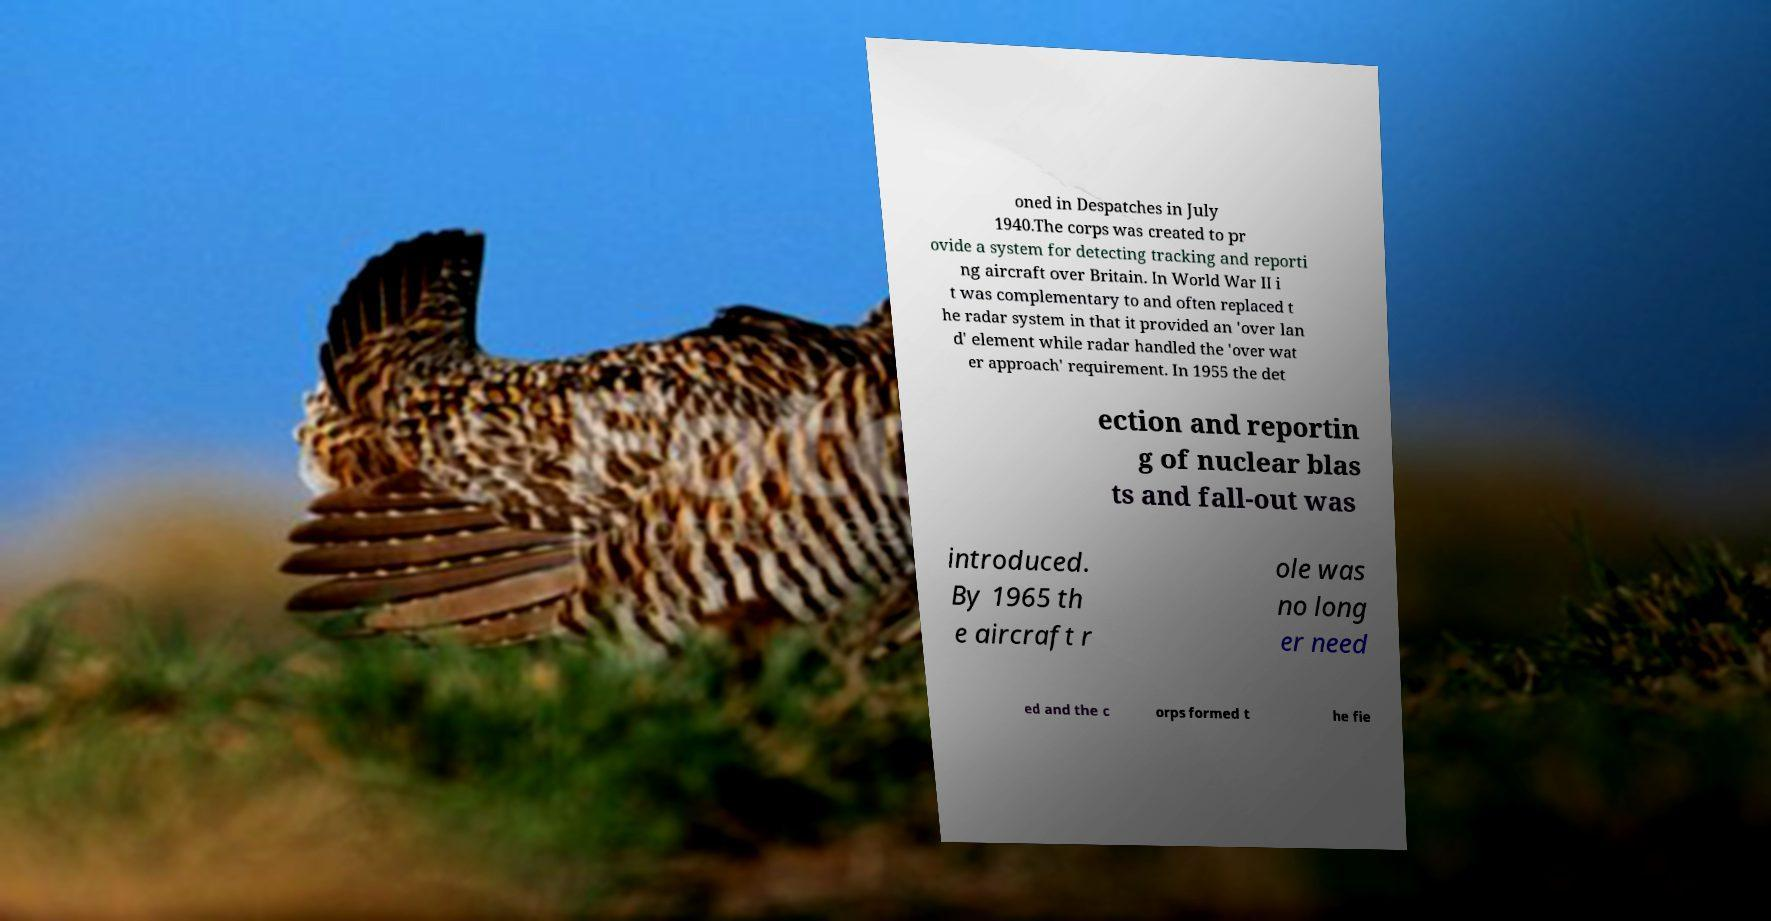Please identify and transcribe the text found in this image. oned in Despatches in July 1940.The corps was created to pr ovide a system for detecting tracking and reporti ng aircraft over Britain. In World War II i t was complementary to and often replaced t he radar system in that it provided an 'over lan d' element while radar handled the 'over wat er approach' requirement. In 1955 the det ection and reportin g of nuclear blas ts and fall-out was introduced. By 1965 th e aircraft r ole was no long er need ed and the c orps formed t he fie 